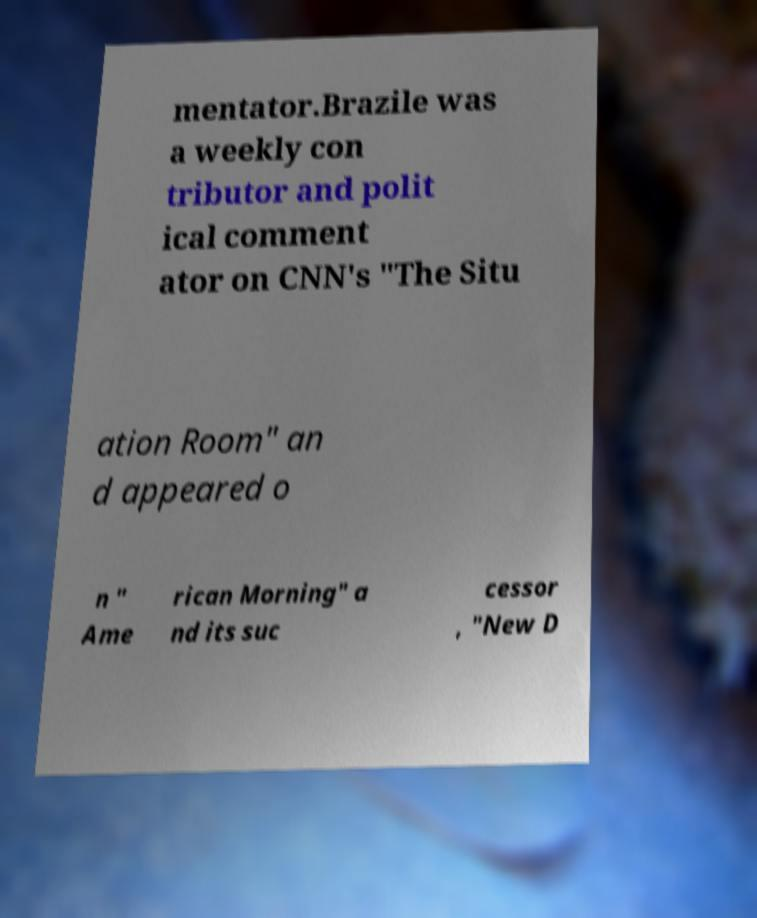Could you extract and type out the text from this image? mentator.Brazile was a weekly con tributor and polit ical comment ator on CNN's "The Situ ation Room" an d appeared o n " Ame rican Morning" a nd its suc cessor , "New D 